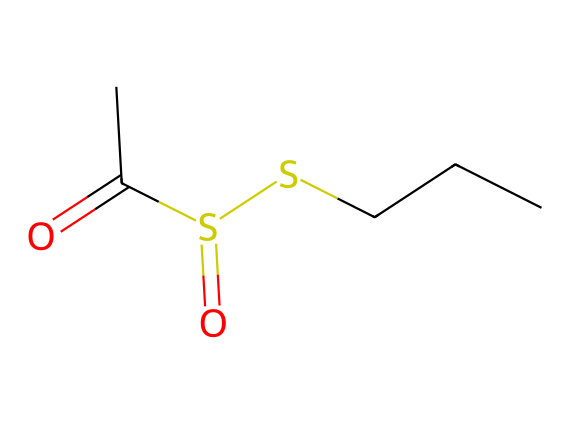What is the chemical name of this compound? The SMILES representation shows a molecule that includes sulfur and is identified as allicin, which is known for its presence in garlic.
Answer: allicin How many sulfur atoms are present in the structure? Analyzing the chemical structure, there are two sulfur atoms as indicated by the "S" symbols in the SMILES.
Answer: two How many carbon atoms are there in the compound? By interpreting the SMILES, the carbon atoms are represented by "C" atoms, and there are five total carbon atoms.
Answer: five What functional groups can be identified in this compound? The structure contains a sulfoxide and a thioester functional group, recognizable by the sulfur atoms and the carbonyl (C=O) linkage.
Answer: sulfoxide and thioester Which type of chemical bond connects the sulfur atoms? The bonding between the sulfur atoms in this structure is via a single covalent bond, as evident from the absence of any symbols indicating double or triple bonds between them.
Answer: single bond What property is mainly responsible for the aroma of garlic? The presence of sulfur in the compound contributes significantly to its strong aroma, particularly due to the allicin structure that releases volatile sulfur compounds.
Answer: sulfur What is the role of allicin in garlic? Allicin serves primarily as a defense mechanism for garlic, protecting it against pests and pathogens with its pungent aroma and antimicrobial properties.
Answer: defense mechanism 